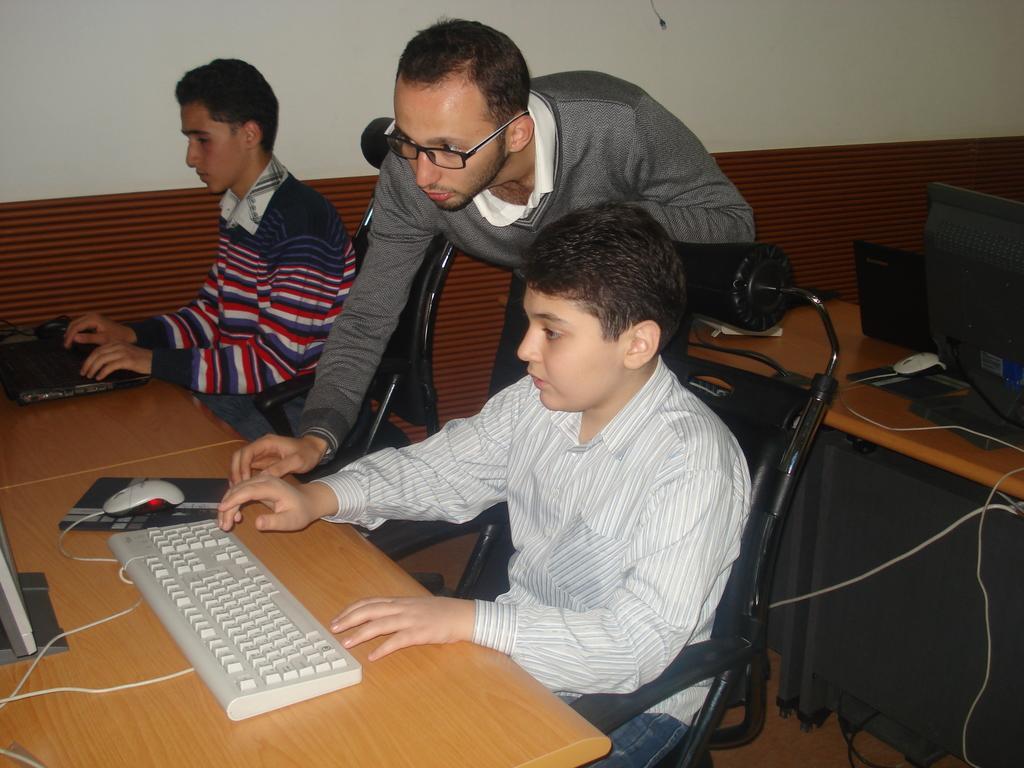Could you give a brief overview of what you see in this image? In the picture I can see a man sitting on a chair and he is working on a laptop. He is wearing a shirt and sweater. There is a boy sitting on the chair and he is wearing a shirt. I can see the computer, keyboard and mouse are kept on the wooden table. There is another man and looks like he is explaining something. I can see another computer and laptop, on the table which is on the right side. 